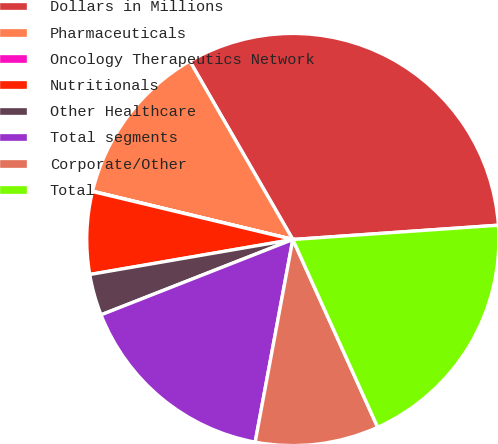Convert chart to OTSL. <chart><loc_0><loc_0><loc_500><loc_500><pie_chart><fcel>Dollars in Millions<fcel>Pharmaceuticals<fcel>Oncology Therapeutics Network<fcel>Nutritionals<fcel>Other Healthcare<fcel>Total segments<fcel>Corporate/Other<fcel>Total<nl><fcel>32.23%<fcel>12.9%<fcel>0.02%<fcel>6.46%<fcel>3.24%<fcel>16.12%<fcel>9.68%<fcel>19.35%<nl></chart> 